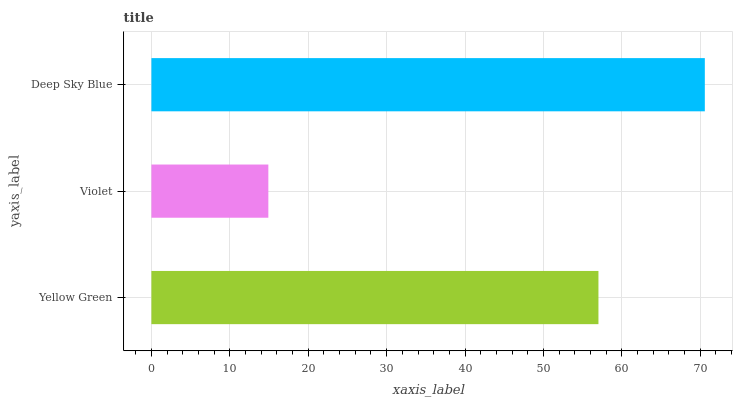Is Violet the minimum?
Answer yes or no. Yes. Is Deep Sky Blue the maximum?
Answer yes or no. Yes. Is Deep Sky Blue the minimum?
Answer yes or no. No. Is Violet the maximum?
Answer yes or no. No. Is Deep Sky Blue greater than Violet?
Answer yes or no. Yes. Is Violet less than Deep Sky Blue?
Answer yes or no. Yes. Is Violet greater than Deep Sky Blue?
Answer yes or no. No. Is Deep Sky Blue less than Violet?
Answer yes or no. No. Is Yellow Green the high median?
Answer yes or no. Yes. Is Yellow Green the low median?
Answer yes or no. Yes. Is Violet the high median?
Answer yes or no. No. Is Deep Sky Blue the low median?
Answer yes or no. No. 